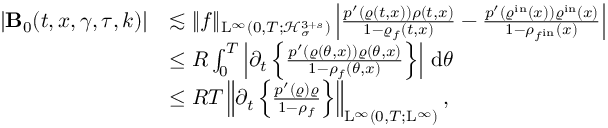<formula> <loc_0><loc_0><loc_500><loc_500>\begin{array} { r l } { | B _ { 0 } ( t , x , \gamma , \tau , k ) | } & { \lesssim \| f \| _ { L ^ { \infty } ( 0 , T ; \mathcal { H } _ { \sigma } ^ { 3 + s } ) } \left | \frac { p ^ { \prime } ( \varrho ( t , x ) ) \rho ( t , x ) } { 1 - \varrho _ { f } ( t , x ) } - \frac { p ^ { \prime } ( \varrho ^ { i n } ( x ) ) \varrho ^ { i n } ( x ) } { 1 - \rho _ { f ^ { i n } } ( x ) } \right | } \\ & { \leq R \int _ { 0 } ^ { T } \left | \partial _ { t } \left \{ \frac { p ^ { \prime } ( \varrho ( \theta , x ) ) \varrho ( \theta , x ) } { 1 - \rho _ { f } ( \theta , x ) } \right \} \right | \, d \theta } \\ & { \leq R T \left \| \partial _ { t } \left \{ \frac { p ^ { \prime } ( \varrho ) \varrho } { 1 - \rho _ { f } } \right \} \right \| _ { L ^ { \infty } ( 0 , T ; L ^ { \infty } ) } , } \end{array}</formula> 